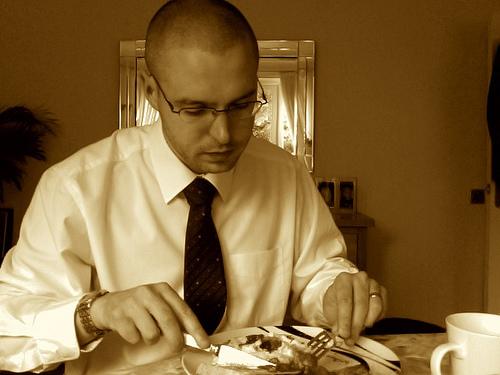What is on the man's neck?
Concise answer only. Tie. Is the man bald by choice?
Quick response, please. Yes. Is this person wearing any jewelry?
Short answer required. Yes. 